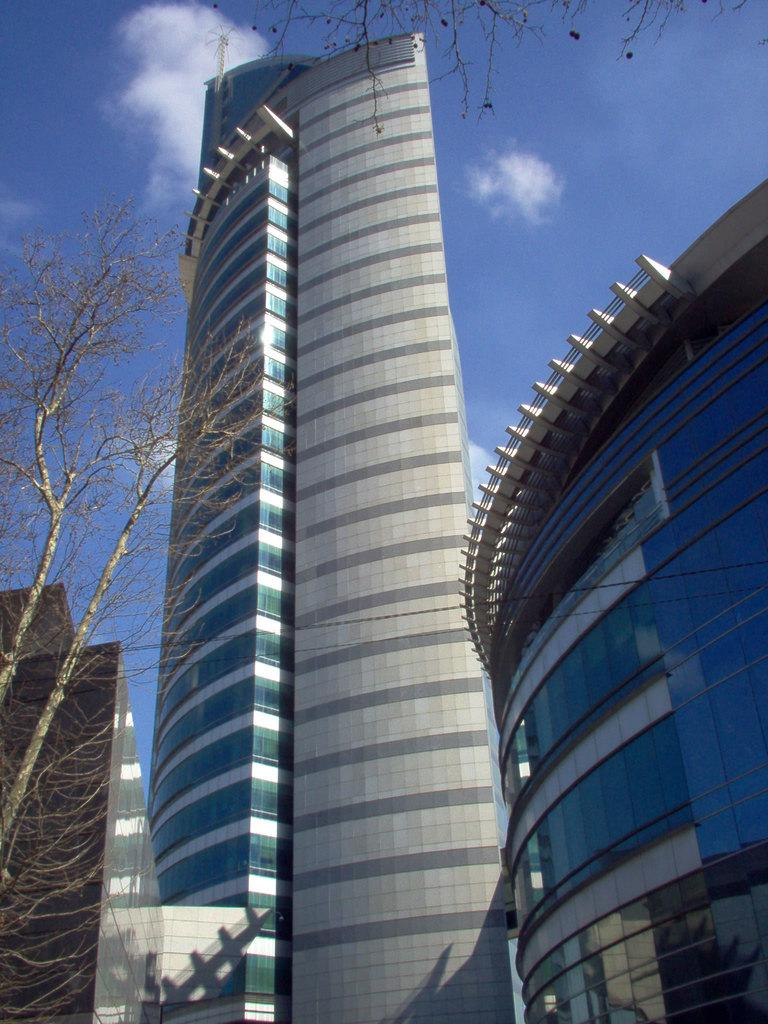What type of structures can be seen in the image? There are buildings in the image. What other natural elements are present in the image? There are trees in the image. What can be seen in the background of the image? The sky is visible in the background of the image. What is the condition of the sky in the image? Clouds are present in the sky. Can you tell me how much the receipt costs in the image? There is no receipt present in the image. What type of umbrella is being used by the person walking in the image? There is no person or umbrella visible in the image. 